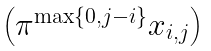Convert formula to latex. <formula><loc_0><loc_0><loc_500><loc_500>\begin{pmatrix} \pi ^ { \max \{ 0 , j - i \} } x _ { i , j } \end{pmatrix}</formula> 